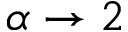<formula> <loc_0><loc_0><loc_500><loc_500>\alpha \rightarrow 2</formula> 